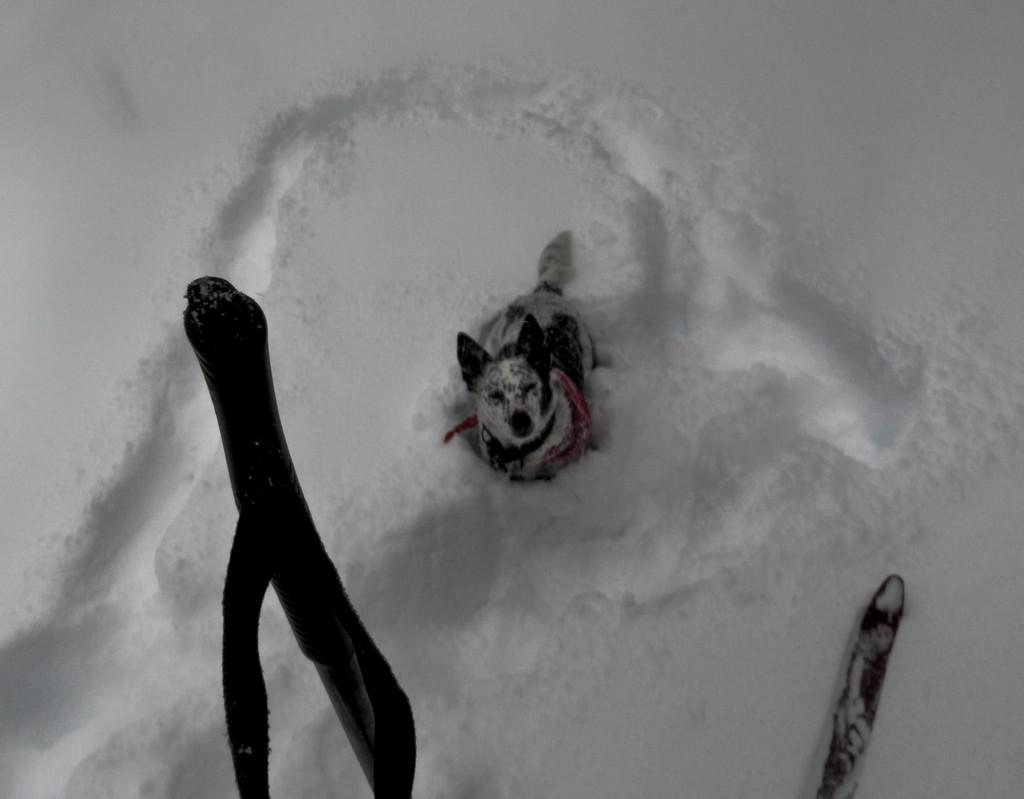What is the condition of the ground in the image? The ground in the image is covered with snow. What animal can be seen in the image? There is a dog in the image. Can you describe the objects at the bottom side of the image? Unfortunately, the provided facts do not give any information about the objects at the bottom side of the image. How many screws are visible in the image? There are no screws present in the image. What fact can be learned from the image about the word "snow"? The image does not provide any information about the word "snow"; it only shows the ground covered with snow. 